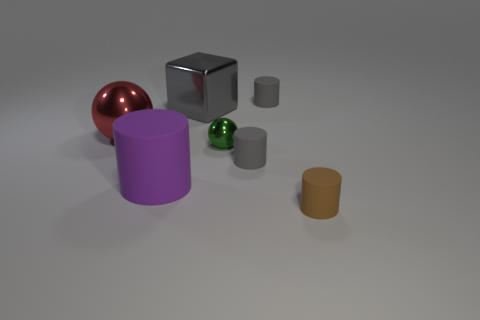Subtract all large purple matte cylinders. How many cylinders are left? 3 Add 2 tiny cylinders. How many objects exist? 9 Subtract all gray cylinders. How many cylinders are left? 2 Subtract all cubes. How many objects are left? 6 Subtract 1 balls. How many balls are left? 1 Subtract all shiny cylinders. Subtract all small cylinders. How many objects are left? 4 Add 4 large purple objects. How many large purple objects are left? 5 Add 5 big yellow metal cylinders. How many big yellow metal cylinders exist? 5 Subtract 0 yellow balls. How many objects are left? 7 Subtract all purple blocks. Subtract all blue cylinders. How many blocks are left? 1 